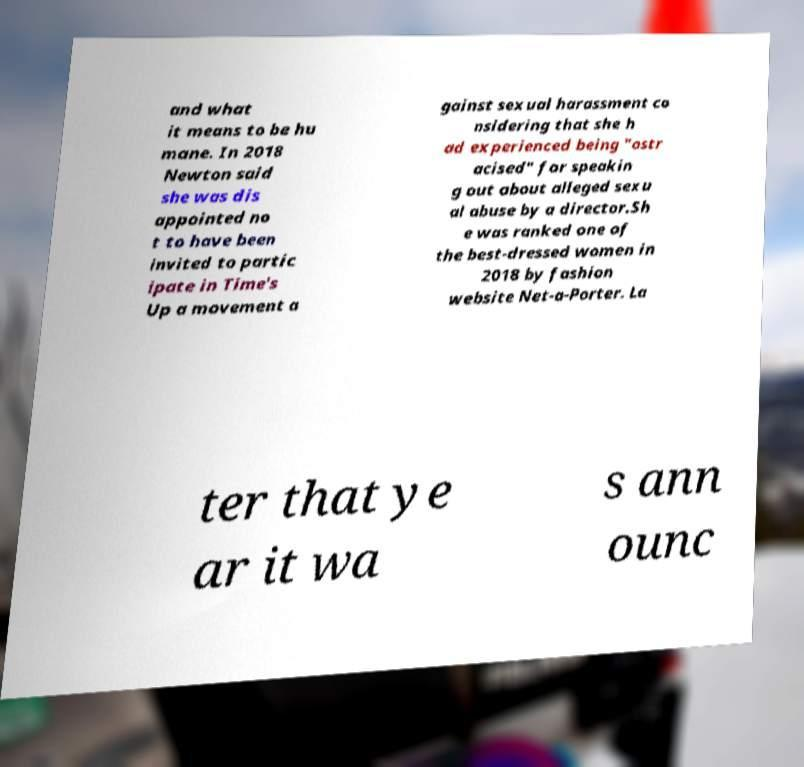Could you extract and type out the text from this image? and what it means to be hu mane. In 2018 Newton said she was dis appointed no t to have been invited to partic ipate in Time's Up a movement a gainst sexual harassment co nsidering that she h ad experienced being "ostr acised" for speakin g out about alleged sexu al abuse by a director.Sh e was ranked one of the best-dressed women in 2018 by fashion website Net-a-Porter. La ter that ye ar it wa s ann ounc 